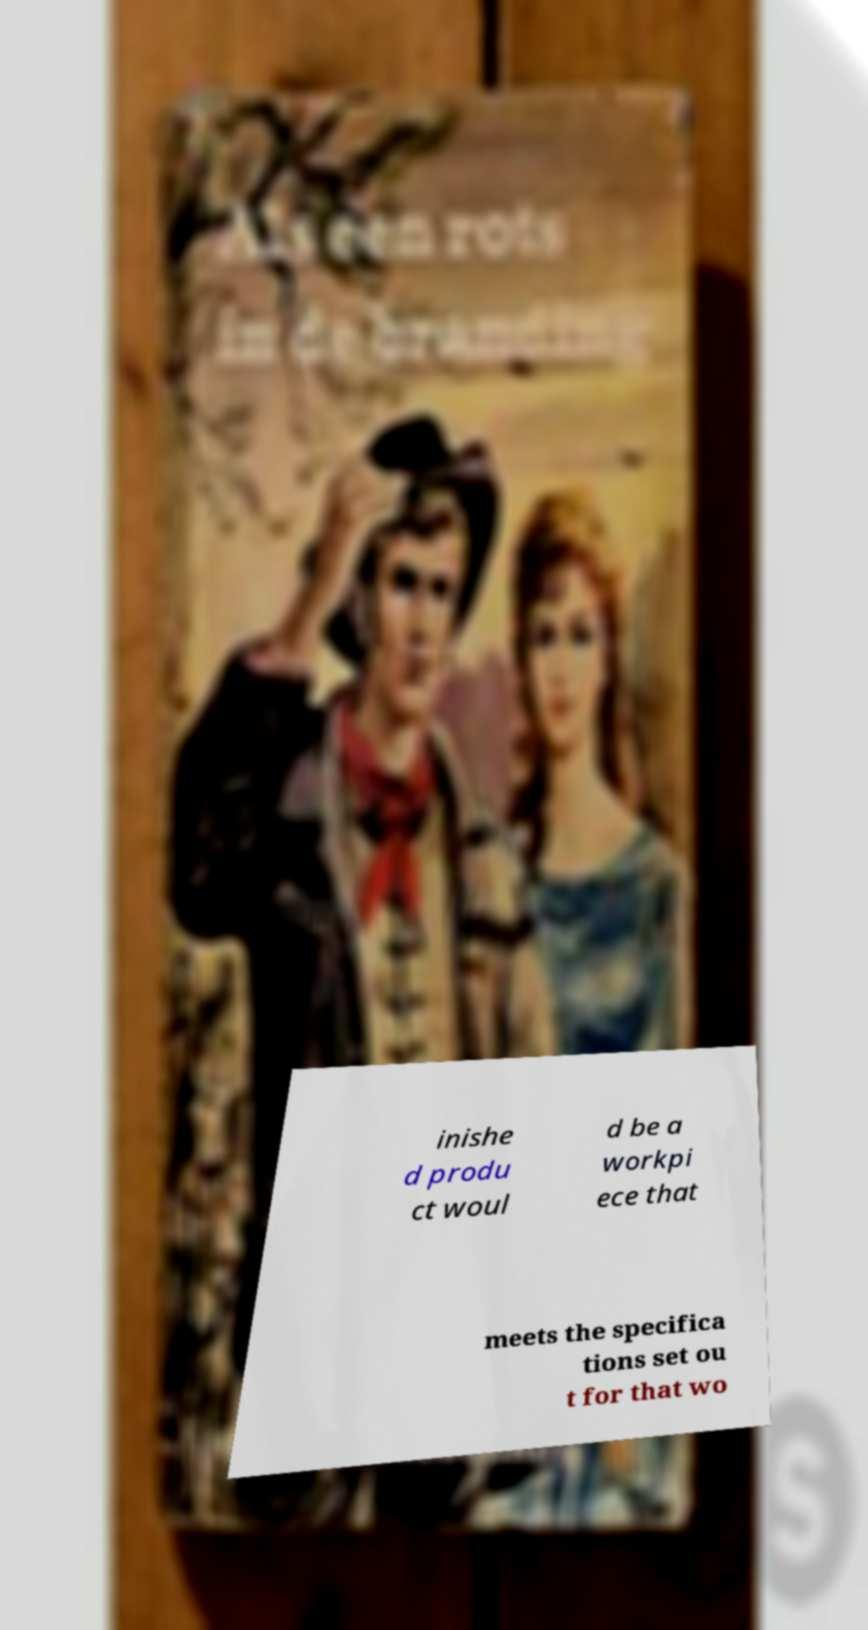What messages or text are displayed in this image? I need them in a readable, typed format. inishe d produ ct woul d be a workpi ece that meets the specifica tions set ou t for that wo 